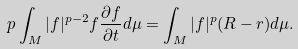<formula> <loc_0><loc_0><loc_500><loc_500>p \int _ { M } | f | ^ { p - 2 } f \frac { \partial f } { \partial t } d \mu = \int _ { M } | f | ^ { p } ( R - r ) d \mu .</formula> 